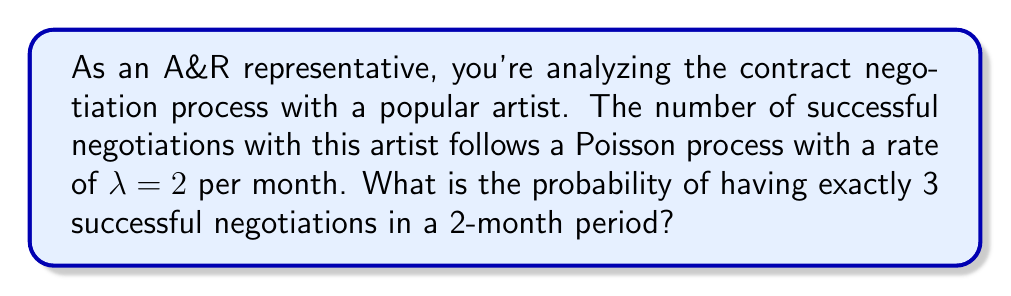Can you solve this math problem? To solve this problem, we'll use the Poisson distribution formula:

$$P(X = k) = \frac{e^{-\lambda t}(\lambda t)^k}{k!}$$

Where:
- $\lambda$ is the rate parameter (2 per month in this case)
- $t$ is the time period (2 months)
- $k$ is the number of events we're interested in (3 successful negotiations)

Steps:
1. Calculate $\lambda t$:
   $\lambda t = 2 \text{ per month} \times 2 \text{ months} = 4$

2. Substitute the values into the Poisson distribution formula:
   $$P(X = 3) = \frac{e^{-4}(4)^3}{3!}$$

3. Evaluate the expression:
   $$P(X = 3) = \frac{e^{-4} \times 64}{6}$$

4. Use a calculator to compute the final result:
   $$P(X = 3) \approx 0.1954$$

This means there's approximately a 19.54% chance of having exactly 3 successful negotiations in a 2-month period.
Answer: 0.1954 